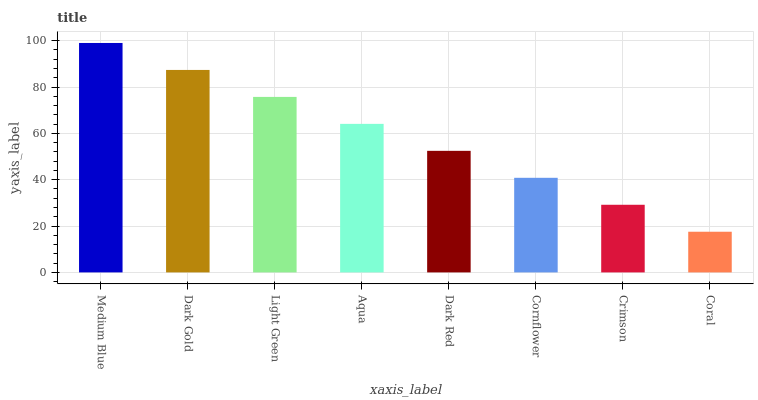Is Dark Gold the minimum?
Answer yes or no. No. Is Dark Gold the maximum?
Answer yes or no. No. Is Medium Blue greater than Dark Gold?
Answer yes or no. Yes. Is Dark Gold less than Medium Blue?
Answer yes or no. Yes. Is Dark Gold greater than Medium Blue?
Answer yes or no. No. Is Medium Blue less than Dark Gold?
Answer yes or no. No. Is Aqua the high median?
Answer yes or no. Yes. Is Dark Red the low median?
Answer yes or no. Yes. Is Cornflower the high median?
Answer yes or no. No. Is Light Green the low median?
Answer yes or no. No. 